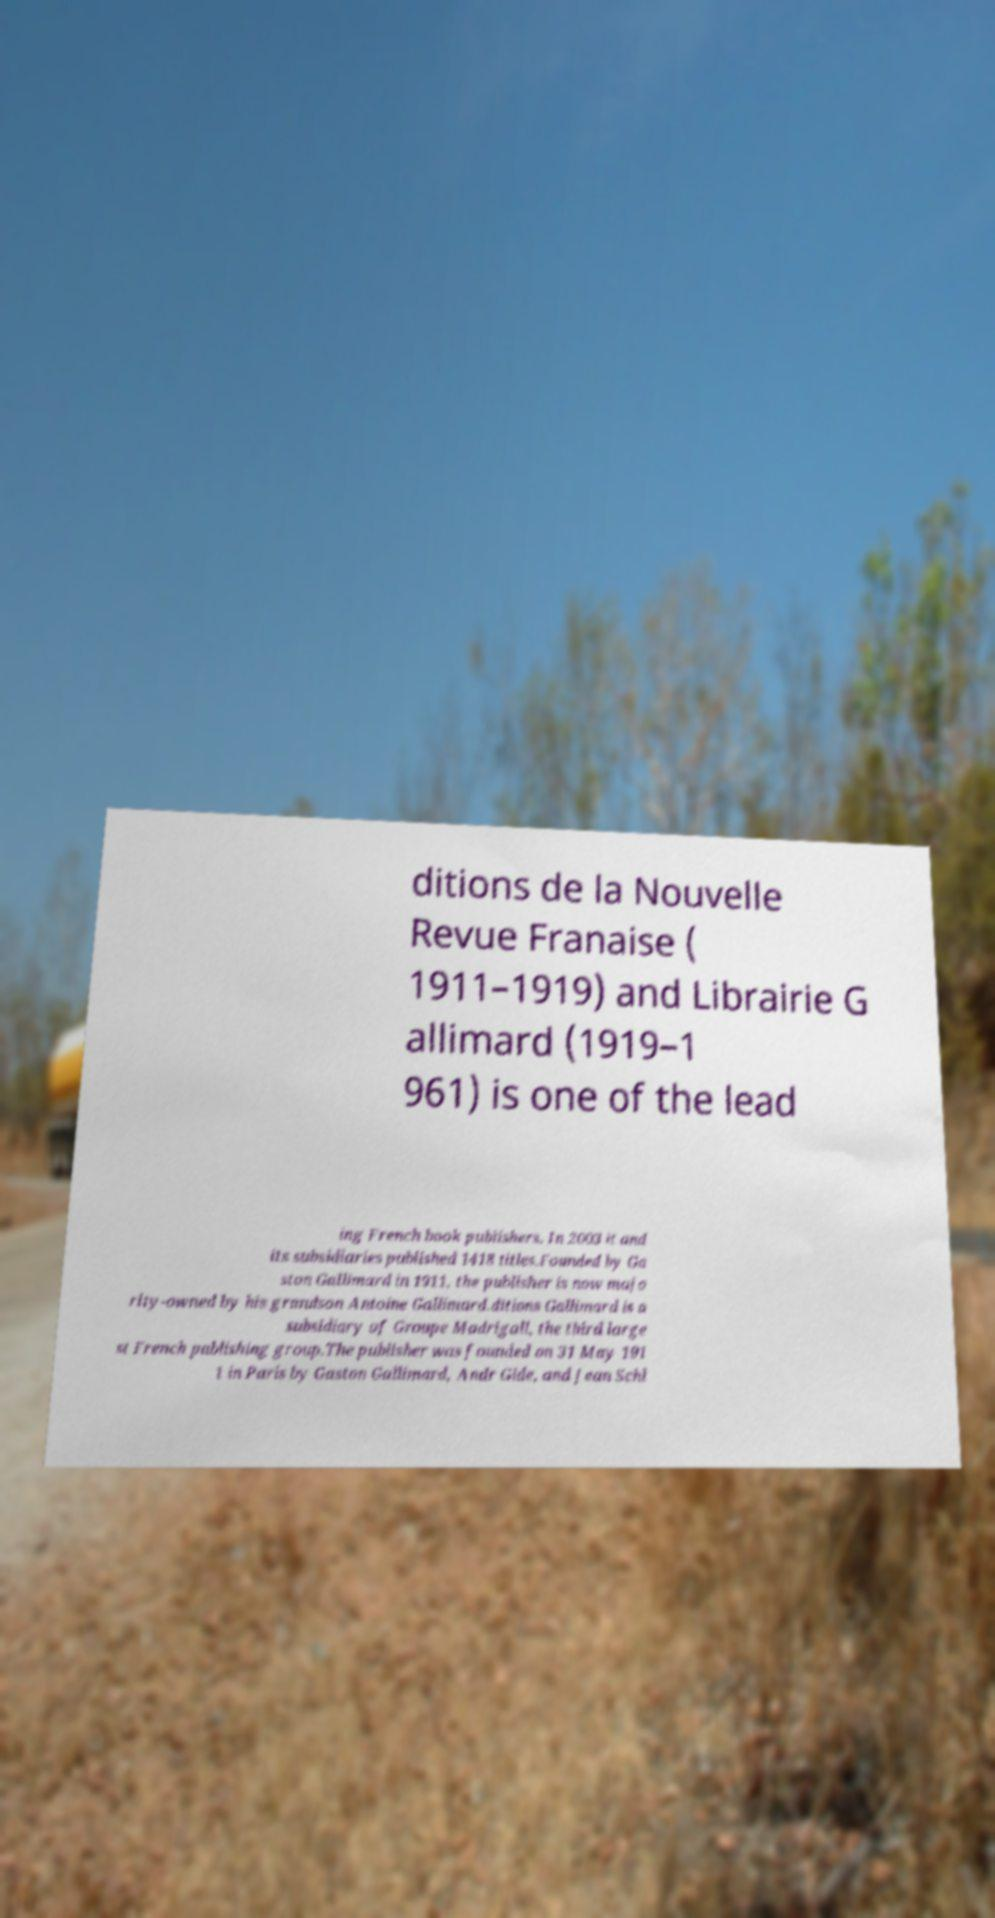Please identify and transcribe the text found in this image. ditions de la Nouvelle Revue Franaise ( 1911–1919) and Librairie G allimard (1919–1 961) is one of the lead ing French book publishers. In 2003 it and its subsidiaries published 1418 titles.Founded by Ga ston Gallimard in 1911, the publisher is now majo rity-owned by his grandson Antoine Gallimard.ditions Gallimard is a subsidiary of Groupe Madrigall, the third large st French publishing group.The publisher was founded on 31 May 191 1 in Paris by Gaston Gallimard, Andr Gide, and Jean Schl 